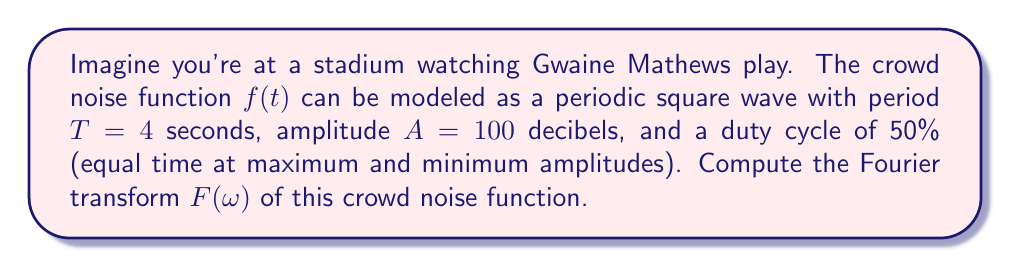What is the answer to this math problem? Let's approach this step-by-step:

1) First, we need to express our square wave mathematically. It can be represented as:

   $$f(t) = \begin{cases} 
   A, & 0 \leq t < T/2 \\
   0, & T/2 \leq t < T
   \end{cases}$$

   This repeats every T seconds.

2) The Fourier transform of a periodic function is a series of impulses at multiples of the fundamental frequency $\omega_0 = 2\pi/T$. The amplitude of each impulse is given by the Fourier series coefficients.

3) For a square wave, the Fourier series coefficients are:

   $$c_n = \frac{A}{2\pi n} (1 - e^{-i\pi n})$$

   where $n$ is any non-zero integer.

4) Substituting our values:
   $A = 100$, $T = 4$, so $\omega_0 = 2\pi/4 = \pi/2$

5) The Fourier transform can be expressed as:

   $$F(\omega) = 2\pi \sum_{n=-\infty, n\neq 0}^{\infty} c_n \delta(\omega - n\omega_0)$$

6) Substituting our $c_n$:

   $$F(\omega) = 2\pi \sum_{n=-\infty, n\neq 0}^{\infty} \frac{100}{2\pi n} (1 - e^{-i\pi n}) \delta(\omega - n\frac{\pi}{2})$$

7) Simplifying:

   $$F(\omega) = 100 \sum_{n=-\infty, n\neq 0}^{\infty} \frac{1 - e^{-i\pi n}}{n} \delta(\omega - n\frac{\pi}{2})$$

8) Note that $1 - e^{-i\pi n} = 0$ for even $n$, and $= 2$ for odd $n$. So we can further simplify:

   $$F(\omega) = 200 \sum_{k=-\infty, k\neq 0}^{\infty} \frac{1}{2k-1} \delta(\omega - (2k-1)\frac{\pi}{2})$$
Answer: $$F(\omega) = 200 \sum_{k=-\infty, k\neq 0}^{\infty} \frac{1}{2k-1} \delta(\omega - (2k-1)\frac{\pi}{2})$$ 